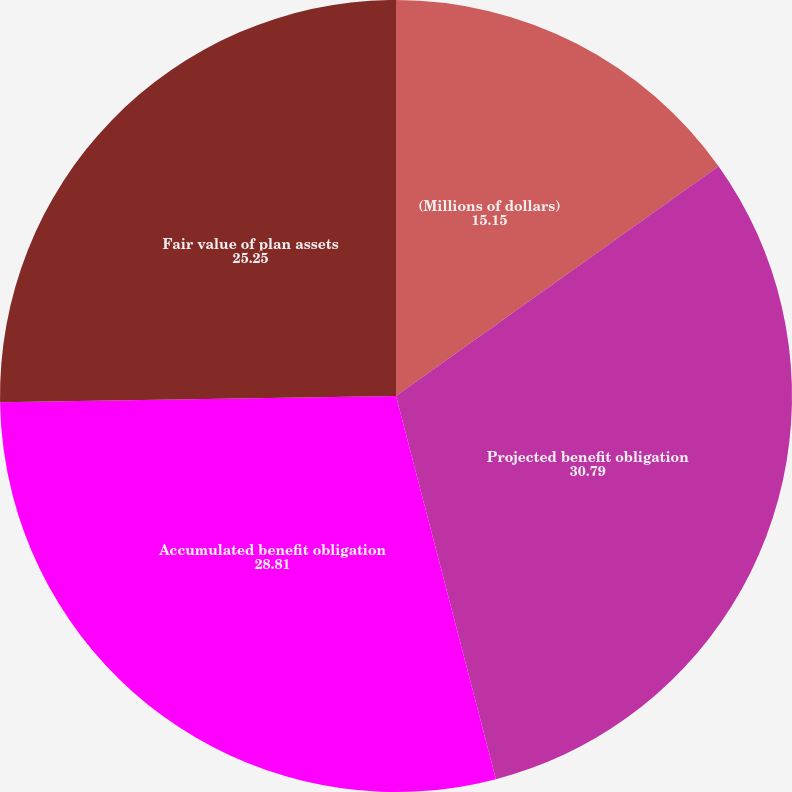<chart> <loc_0><loc_0><loc_500><loc_500><pie_chart><fcel>(Millions of dollars)<fcel>Projected benefit obligation<fcel>Accumulated benefit obligation<fcel>Fair value of plan assets<nl><fcel>15.15%<fcel>30.79%<fcel>28.81%<fcel>25.25%<nl></chart> 